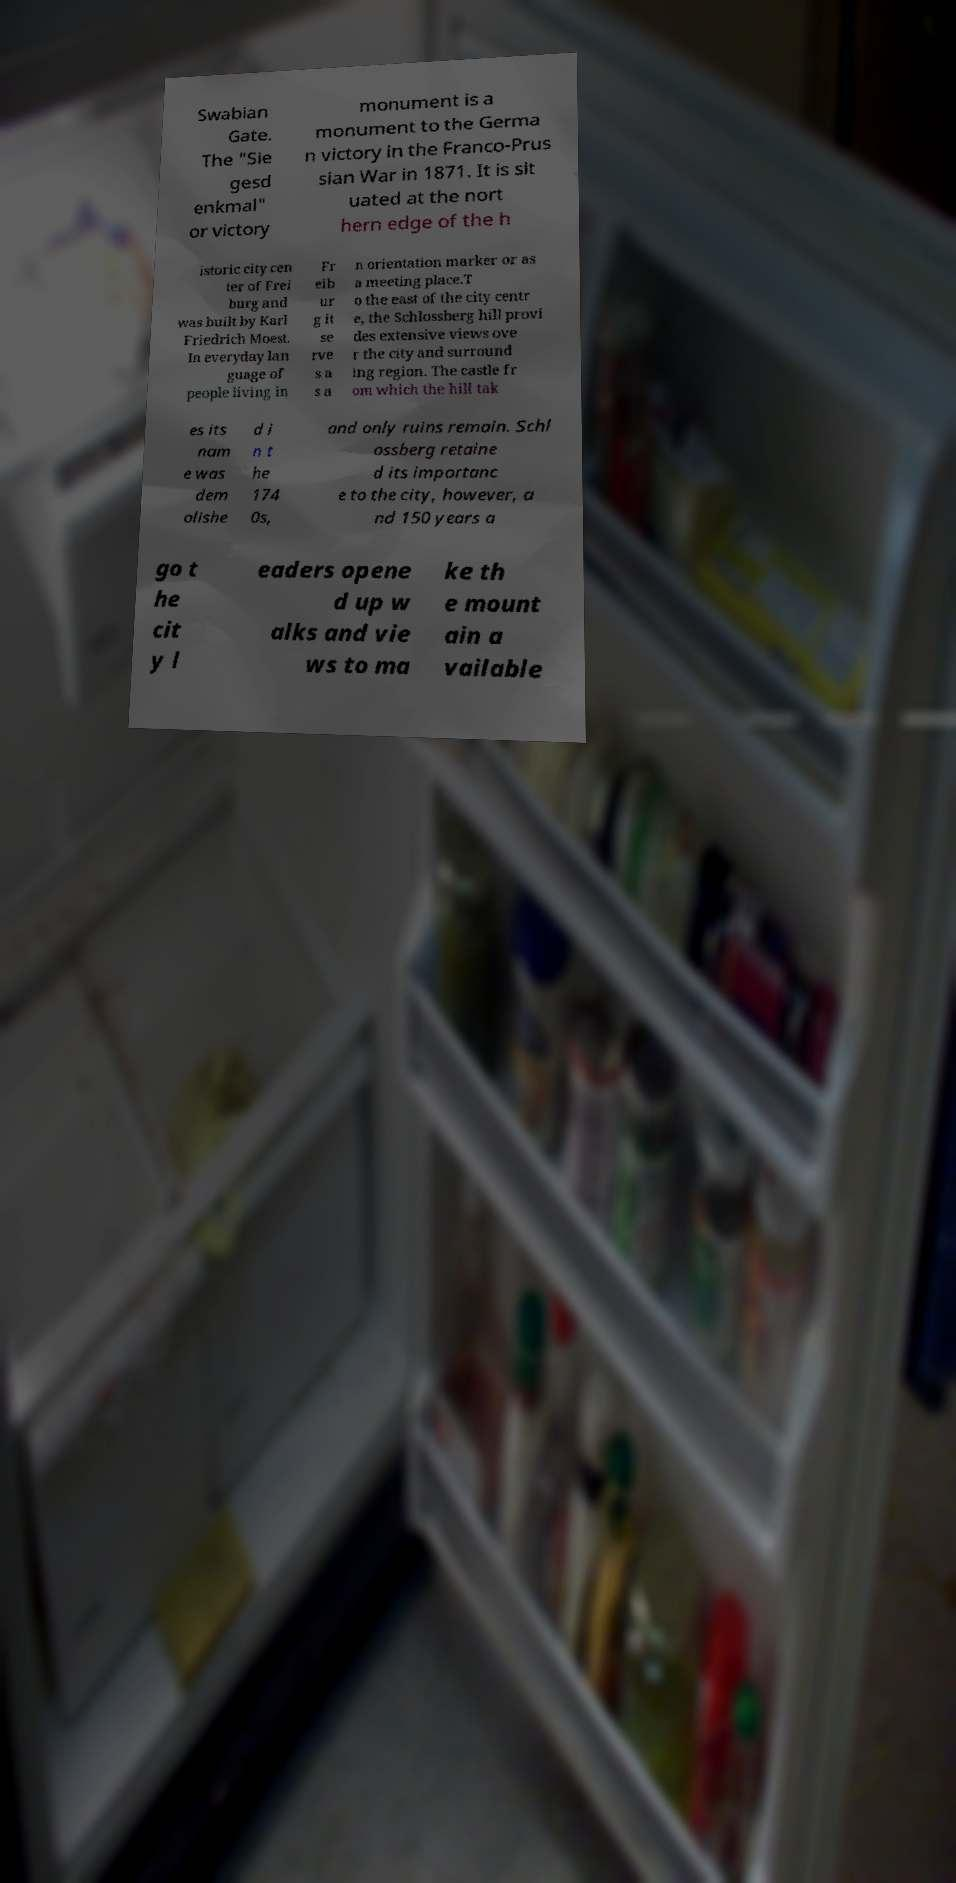For documentation purposes, I need the text within this image transcribed. Could you provide that? Swabian Gate. The "Sie gesd enkmal" or victory monument is a monument to the Germa n victory in the Franco-Prus sian War in 1871. It is sit uated at the nort hern edge of the h istoric city cen ter of Frei burg and was built by Karl Friedrich Moest. In everyday lan guage of people living in Fr eib ur g it se rve s a s a n orientation marker or as a meeting place.T o the east of the city centr e, the Schlossberg hill provi des extensive views ove r the city and surround ing region. The castle fr om which the hill tak es its nam e was dem olishe d i n t he 174 0s, and only ruins remain. Schl ossberg retaine d its importanc e to the city, however, a nd 150 years a go t he cit y l eaders opene d up w alks and vie ws to ma ke th e mount ain a vailable 